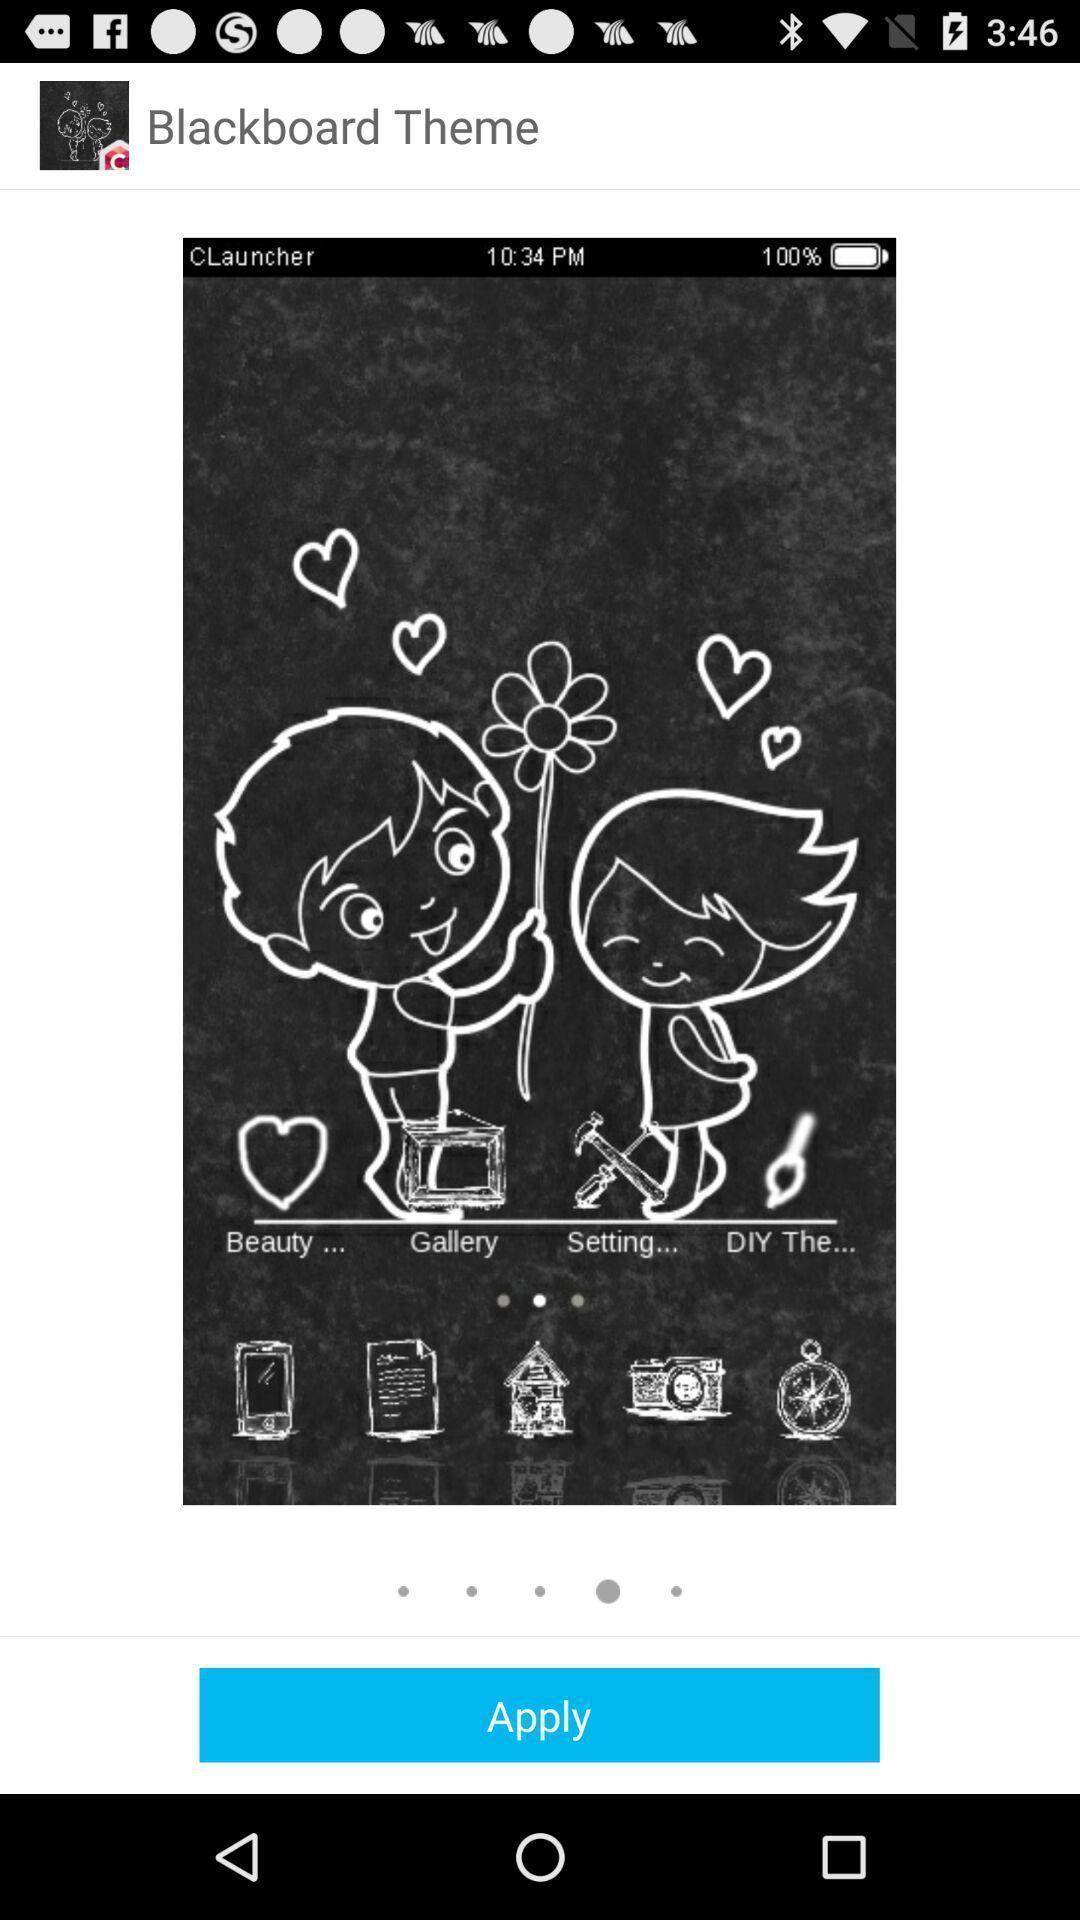Describe the content in this image. Screen shows theme with an image to apply. 